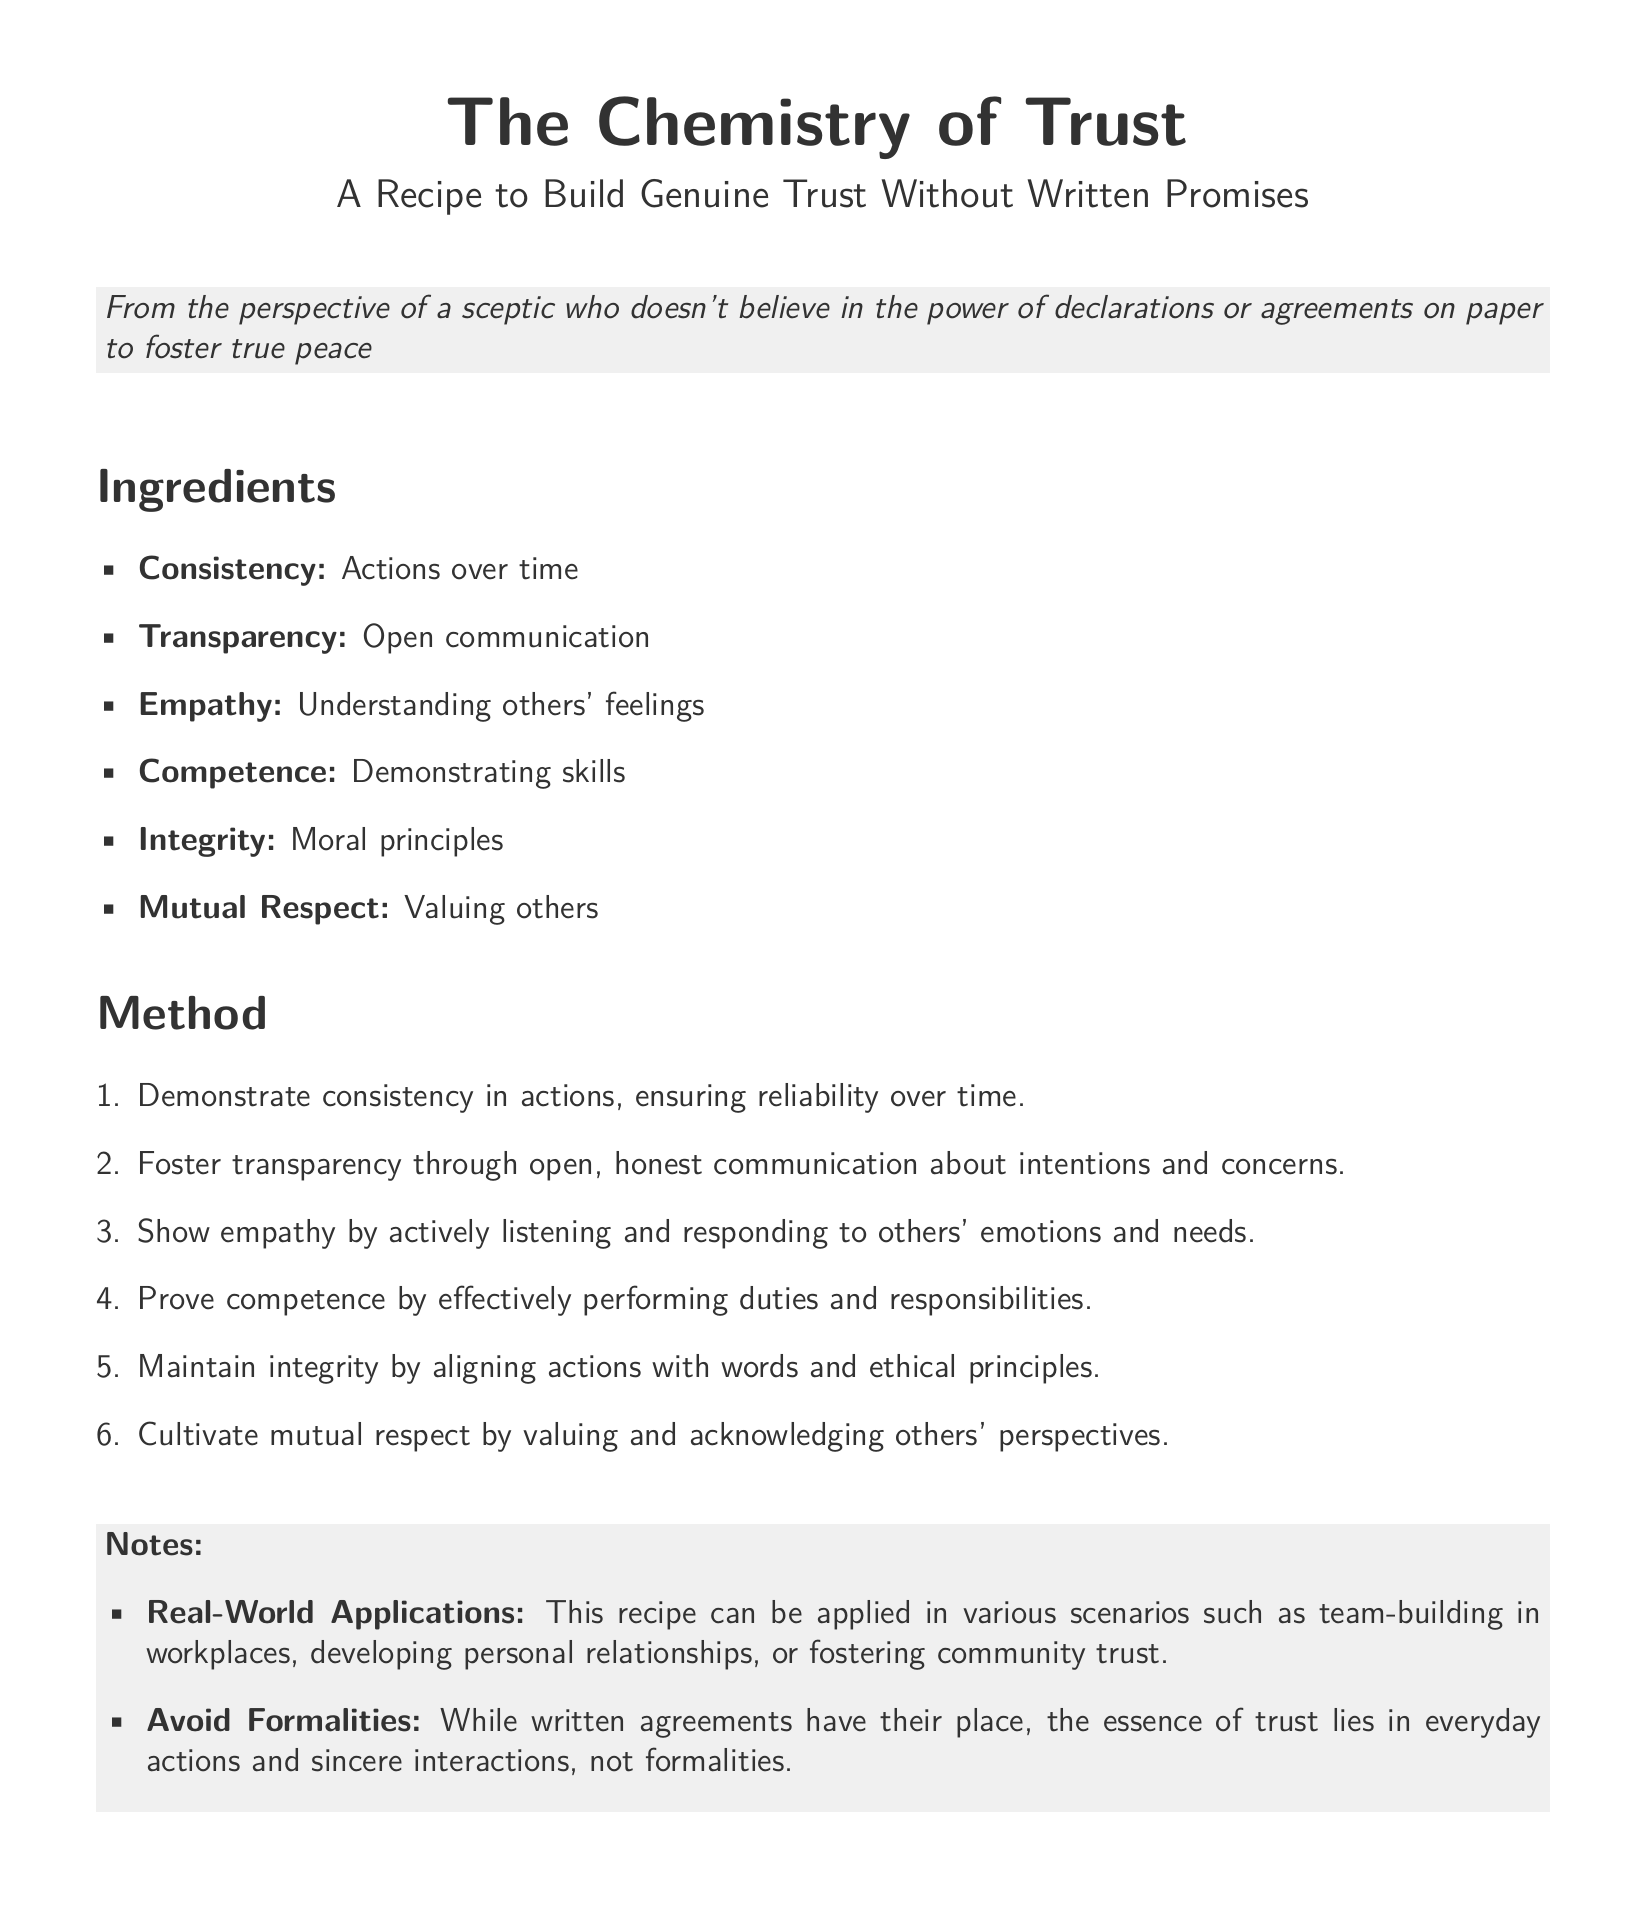What are the ingredients? The ingredients are listed in the document, detailing the essential components needed to build trust.
Answer: Consistency, Transparency, Empathy, Competence, Integrity, Mutual Respect How many steps are in the method? The method outlines a series of steps, which can be counted for quantification.
Answer: 6 What does the recipe emphasize instead of written agreements? The document highlights the essence of trust in terms of behaviors and interactions rather than formal documents.
Answer: Everyday actions and sincere interactions What is the main theme of the recipe? The overall focus of the recipe card is summarized in its title that speaks to building trust genuinely.
Answer: The Chemistry of Trust What should be maintained according to the ingredients list? The ingredients suggest a crucial aspect that pertains to moral and ethical standards in relationships.
Answer: Integrity 